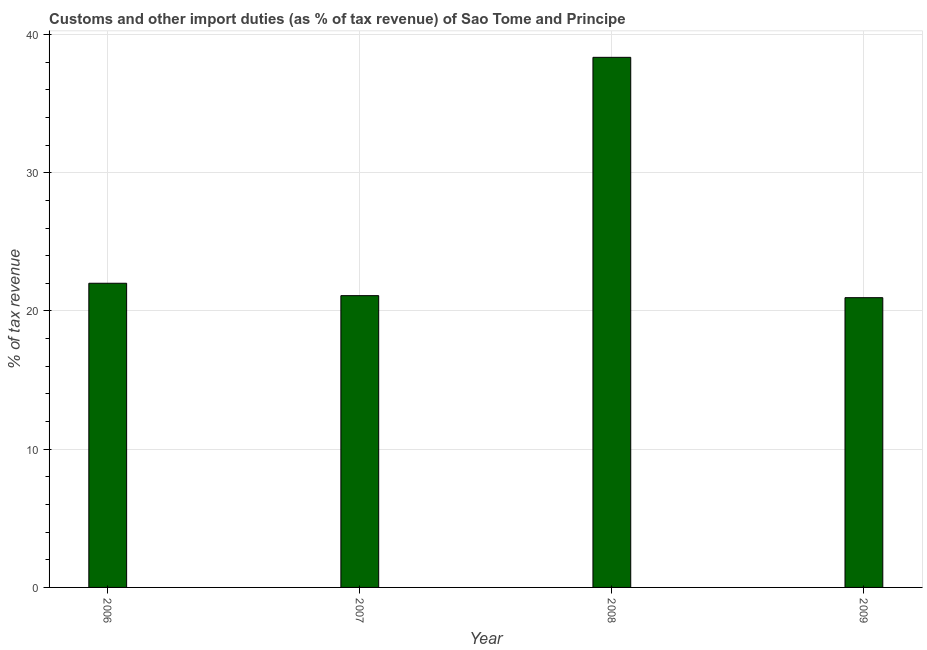What is the title of the graph?
Provide a succinct answer. Customs and other import duties (as % of tax revenue) of Sao Tome and Principe. What is the label or title of the Y-axis?
Your answer should be very brief. % of tax revenue. What is the customs and other import duties in 2006?
Ensure brevity in your answer.  22. Across all years, what is the maximum customs and other import duties?
Make the answer very short. 38.35. Across all years, what is the minimum customs and other import duties?
Give a very brief answer. 20.96. In which year was the customs and other import duties minimum?
Offer a very short reply. 2009. What is the sum of the customs and other import duties?
Provide a succinct answer. 102.42. What is the difference between the customs and other import duties in 2006 and 2009?
Provide a short and direct response. 1.04. What is the average customs and other import duties per year?
Ensure brevity in your answer.  25.61. What is the median customs and other import duties?
Your response must be concise. 21.56. Do a majority of the years between 2008 and 2007 (inclusive) have customs and other import duties greater than 6 %?
Your answer should be very brief. No. What is the ratio of the customs and other import duties in 2008 to that in 2009?
Offer a terse response. 1.83. Is the customs and other import duties in 2007 less than that in 2009?
Offer a terse response. No. Is the difference between the customs and other import duties in 2006 and 2007 greater than the difference between any two years?
Give a very brief answer. No. What is the difference between the highest and the second highest customs and other import duties?
Offer a terse response. 16.34. What is the difference between the highest and the lowest customs and other import duties?
Your answer should be very brief. 17.39. Are all the bars in the graph horizontal?
Give a very brief answer. No. How many years are there in the graph?
Your answer should be compact. 4. What is the difference between two consecutive major ticks on the Y-axis?
Offer a very short reply. 10. Are the values on the major ticks of Y-axis written in scientific E-notation?
Your answer should be compact. No. What is the % of tax revenue in 2006?
Your answer should be compact. 22. What is the % of tax revenue in 2007?
Give a very brief answer. 21.11. What is the % of tax revenue in 2008?
Your response must be concise. 38.35. What is the % of tax revenue in 2009?
Your answer should be compact. 20.96. What is the difference between the % of tax revenue in 2006 and 2007?
Provide a short and direct response. 0.9. What is the difference between the % of tax revenue in 2006 and 2008?
Make the answer very short. -16.34. What is the difference between the % of tax revenue in 2006 and 2009?
Your response must be concise. 1.04. What is the difference between the % of tax revenue in 2007 and 2008?
Provide a succinct answer. -17.24. What is the difference between the % of tax revenue in 2007 and 2009?
Offer a very short reply. 0.15. What is the difference between the % of tax revenue in 2008 and 2009?
Offer a very short reply. 17.39. What is the ratio of the % of tax revenue in 2006 to that in 2007?
Offer a terse response. 1.04. What is the ratio of the % of tax revenue in 2006 to that in 2008?
Give a very brief answer. 0.57. What is the ratio of the % of tax revenue in 2006 to that in 2009?
Your response must be concise. 1.05. What is the ratio of the % of tax revenue in 2007 to that in 2008?
Your response must be concise. 0.55. What is the ratio of the % of tax revenue in 2008 to that in 2009?
Ensure brevity in your answer.  1.83. 